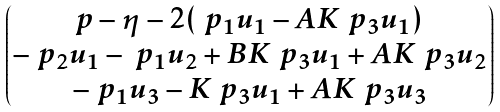Convert formula to latex. <formula><loc_0><loc_0><loc_500><loc_500>\begin{pmatrix} p - \eta - 2 ( \ p _ { 1 } u _ { 1 } - A K \ p _ { 3 } u _ { 1 } ) \\ - \ p _ { 2 } u _ { 1 } - \ p _ { 1 } u _ { 2 } + B K \ p _ { 3 } u _ { 1 } + A K \ p _ { 3 } u _ { 2 } \\ - \ p _ { 1 } u _ { 3 } - K \ p _ { 3 } u _ { 1 } + A K \ p _ { 3 } u _ { 3 } \end{pmatrix}</formula> 